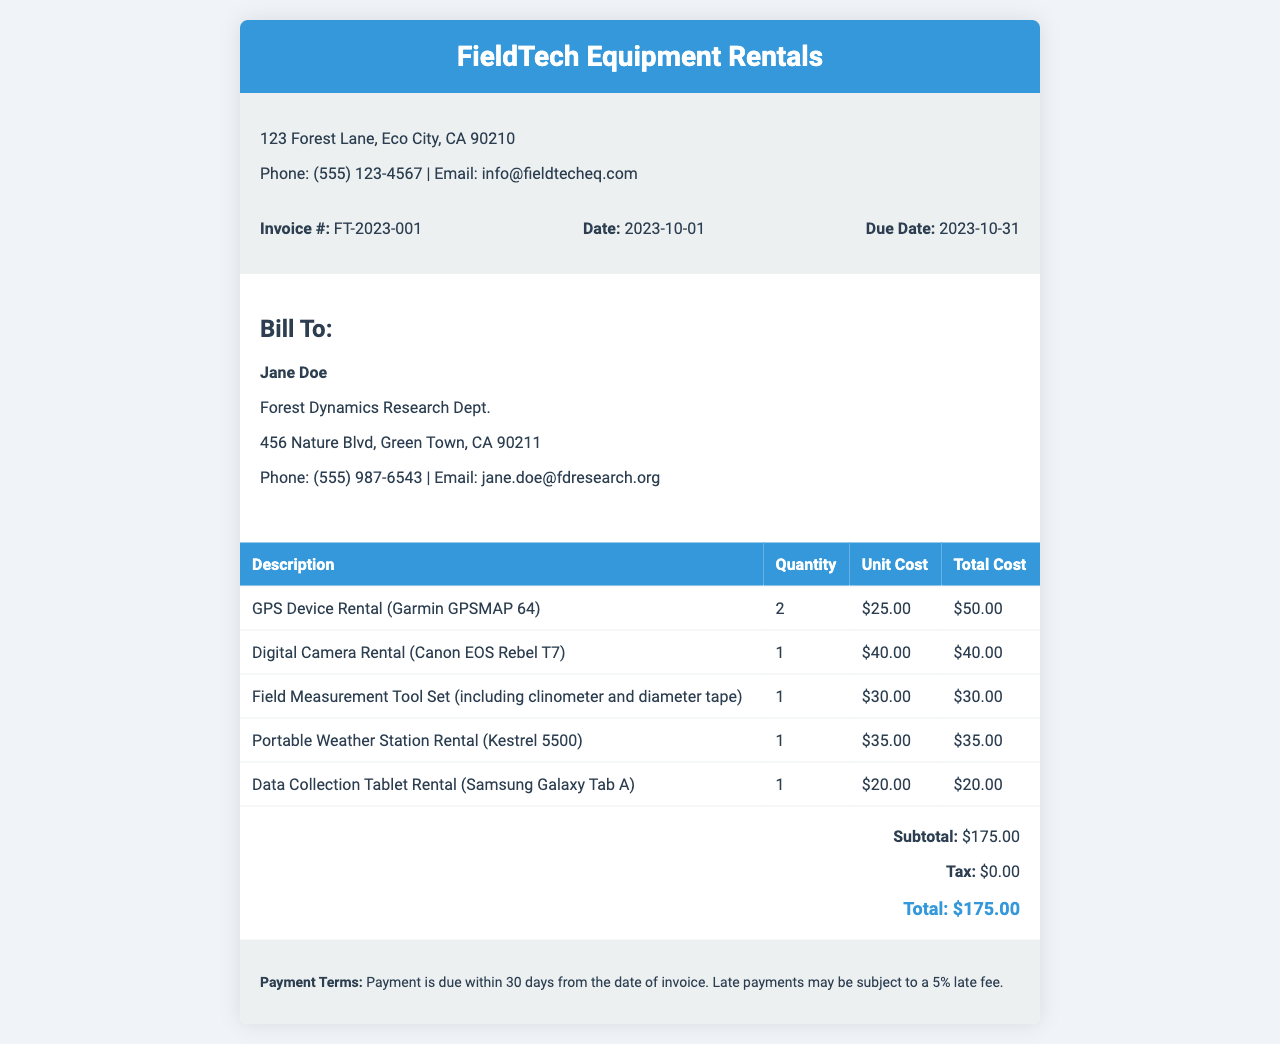What is the invoice number? The invoice number is listed in the document under the invoice details section.
Answer: FT-2023-001 What is the due date? The due date is specified in the invoice details section as the deadline for payment.
Answer: 2023-10-31 Who is billed for the rental? The "Bill To" section provides the name of the individual or entity being billed.
Answer: Jane Doe How many GPS devices were rented? The quantity of GPS devices rented is detailed in the itemized list of the invoice.
Answer: 2 What is the total cost before tax? The subtotal in the summary section shows the total before any taxes are applied.
Answer: $175.00 What type of digital camera was rented? The itemized list specifies the model of the digital camera rented.
Answer: Canon EOS Rebel T7 What is the rental cost for the Data Collection Tablet? The document lists the unit cost and total cost for the Data Collection Tablet item.
Answer: $20.00 Is there any tax charged on this invoice? The tax amount is provided in the summary section of the invoice.
Answer: $0.00 What payment terms are mentioned? The payment terms provide conditions regarding payment timeline and penalties for late payments.
Answer: Payment is due within 30 days from the date of invoice 